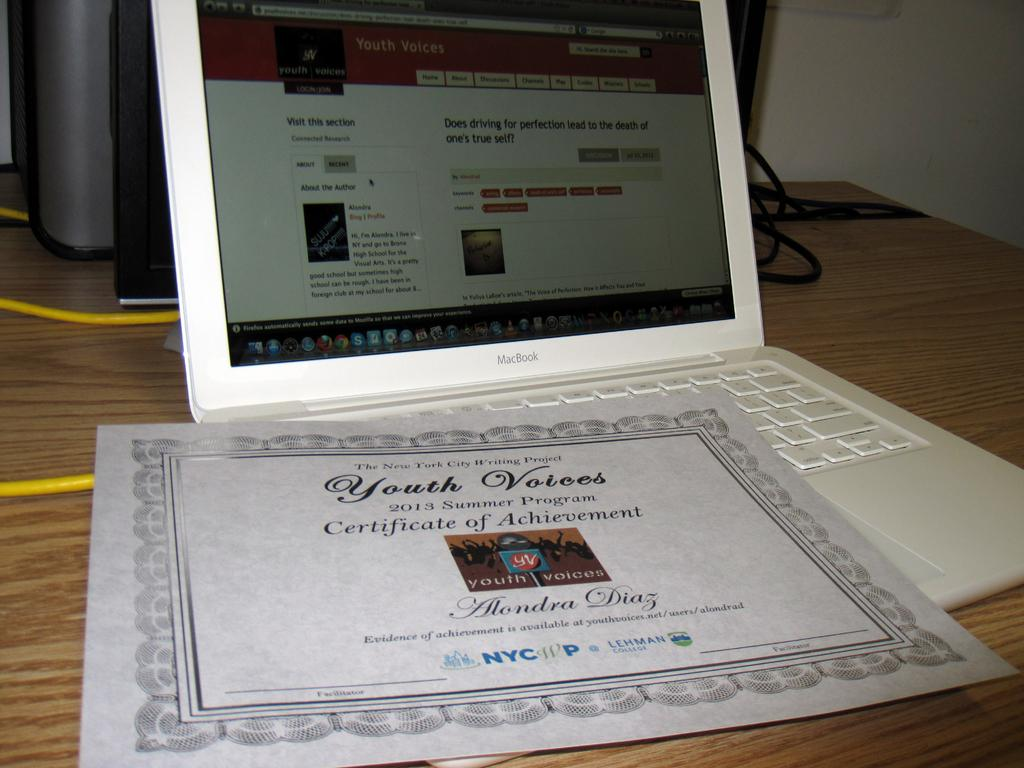<image>
Offer a succinct explanation of the picture presented. A certificate for Youth Voices on top of a white Macbook. 